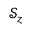<formula> <loc_0><loc_0><loc_500><loc_500>\mathcal { S } _ { z }</formula> 